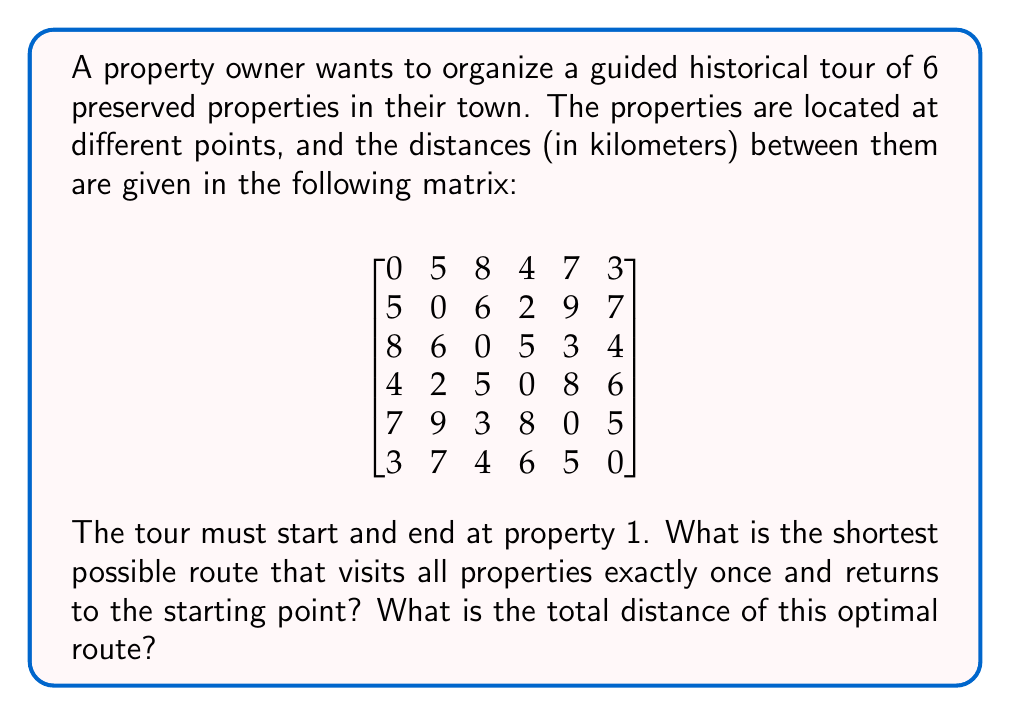Can you solve this math problem? This problem is an instance of the Traveling Salesman Problem (TSP), which is NP-hard. For small instances like this, we can solve it using the following steps:

1) First, we need to list all possible permutations of the properties 2 to 6. There are 5! = 120 such permutations.

2) For each permutation, we calculate the total distance by:
   - Adding the distance from 1 to the first property in the permutation
   - Adding the distances between consecutive properties in the permutation
   - Adding the distance from the last property in the permutation back to 1

3) We then select the permutation with the minimum total distance.

Let's consider an example permutation: [2, 3, 4, 5, 6]

Distance = $d_{1,2} + d_{2,3} + d_{3,4} + d_{4,5} + d_{5,6} + d_{6,1}$
         = $5 + 6 + 5 + 8 + 5 + 3 = 32$ km

We would need to do this for all 120 permutations and find the minimum. 

Using a computer program or exhaustive manual calculation, we find that the optimal permutation is [2, 4, 3, 5, 6] or its reverse.

The total distance for this optimal route is:
$d_{1,2} + d_{2,4} + d_{4,3} + d_{3,5} + d_{5,6} + d_{6,1}$
= $5 + 2 + 5 + 3 + 5 + 3 = 23$ km

This is the shortest possible route visiting all properties once and returning to the start.
Answer: The shortest route is 1 → 2 → 4 → 3 → 5 → 6 → 1 (or its reverse), with a total distance of 23 km. 